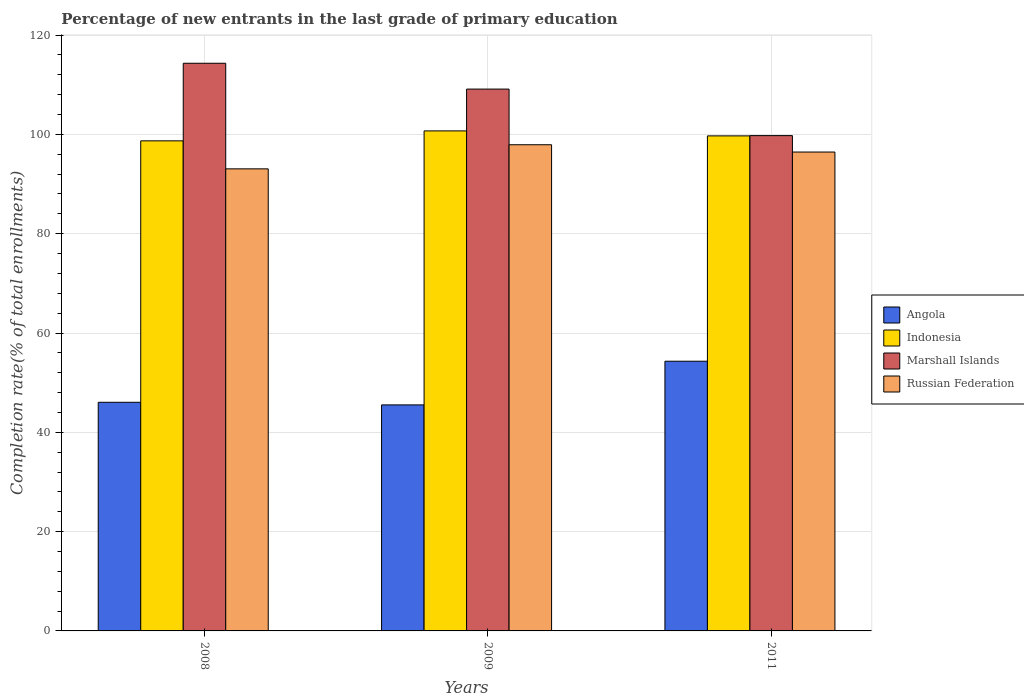How many different coloured bars are there?
Your answer should be very brief. 4. Are the number of bars per tick equal to the number of legend labels?
Your answer should be compact. Yes. Are the number of bars on each tick of the X-axis equal?
Give a very brief answer. Yes. How many bars are there on the 2nd tick from the left?
Ensure brevity in your answer.  4. What is the label of the 1st group of bars from the left?
Give a very brief answer. 2008. What is the percentage of new entrants in Russian Federation in 2009?
Offer a terse response. 97.91. Across all years, what is the maximum percentage of new entrants in Marshall Islands?
Your answer should be very brief. 114.33. Across all years, what is the minimum percentage of new entrants in Marshall Islands?
Give a very brief answer. 99.75. In which year was the percentage of new entrants in Marshall Islands minimum?
Offer a terse response. 2011. What is the total percentage of new entrants in Indonesia in the graph?
Provide a succinct answer. 299.1. What is the difference between the percentage of new entrants in Angola in 2008 and that in 2009?
Provide a short and direct response. 0.53. What is the difference between the percentage of new entrants in Indonesia in 2008 and the percentage of new entrants in Russian Federation in 2009?
Provide a succinct answer. 0.79. What is the average percentage of new entrants in Russian Federation per year?
Ensure brevity in your answer.  95.81. In the year 2009, what is the difference between the percentage of new entrants in Angola and percentage of new entrants in Russian Federation?
Your response must be concise. -52.39. What is the ratio of the percentage of new entrants in Russian Federation in 2009 to that in 2011?
Your answer should be compact. 1.02. What is the difference between the highest and the second highest percentage of new entrants in Russian Federation?
Your response must be concise. 1.47. What is the difference between the highest and the lowest percentage of new entrants in Russian Federation?
Your answer should be very brief. 4.85. What does the 4th bar from the left in 2009 represents?
Your response must be concise. Russian Federation. What does the 3rd bar from the right in 2008 represents?
Provide a succinct answer. Indonesia. Is it the case that in every year, the sum of the percentage of new entrants in Russian Federation and percentage of new entrants in Marshall Islands is greater than the percentage of new entrants in Angola?
Ensure brevity in your answer.  Yes. Are the values on the major ticks of Y-axis written in scientific E-notation?
Keep it short and to the point. No. How many legend labels are there?
Keep it short and to the point. 4. What is the title of the graph?
Your answer should be very brief. Percentage of new entrants in the last grade of primary education. What is the label or title of the X-axis?
Provide a short and direct response. Years. What is the label or title of the Y-axis?
Keep it short and to the point. Completion rate(% of total enrollments). What is the Completion rate(% of total enrollments) in Angola in 2008?
Give a very brief answer. 46.05. What is the Completion rate(% of total enrollments) in Indonesia in 2008?
Your answer should be compact. 98.7. What is the Completion rate(% of total enrollments) of Marshall Islands in 2008?
Your response must be concise. 114.33. What is the Completion rate(% of total enrollments) of Russian Federation in 2008?
Offer a very short reply. 93.06. What is the Completion rate(% of total enrollments) of Angola in 2009?
Offer a terse response. 45.52. What is the Completion rate(% of total enrollments) in Indonesia in 2009?
Offer a terse response. 100.7. What is the Completion rate(% of total enrollments) of Marshall Islands in 2009?
Provide a short and direct response. 109.12. What is the Completion rate(% of total enrollments) in Russian Federation in 2009?
Your answer should be compact. 97.91. What is the Completion rate(% of total enrollments) in Angola in 2011?
Your response must be concise. 54.32. What is the Completion rate(% of total enrollments) of Indonesia in 2011?
Provide a succinct answer. 99.7. What is the Completion rate(% of total enrollments) of Marshall Islands in 2011?
Ensure brevity in your answer.  99.75. What is the Completion rate(% of total enrollments) in Russian Federation in 2011?
Offer a terse response. 96.45. Across all years, what is the maximum Completion rate(% of total enrollments) in Angola?
Your answer should be very brief. 54.32. Across all years, what is the maximum Completion rate(% of total enrollments) in Indonesia?
Give a very brief answer. 100.7. Across all years, what is the maximum Completion rate(% of total enrollments) in Marshall Islands?
Your answer should be compact. 114.33. Across all years, what is the maximum Completion rate(% of total enrollments) in Russian Federation?
Provide a succinct answer. 97.91. Across all years, what is the minimum Completion rate(% of total enrollments) in Angola?
Keep it short and to the point. 45.52. Across all years, what is the minimum Completion rate(% of total enrollments) in Indonesia?
Your response must be concise. 98.7. Across all years, what is the minimum Completion rate(% of total enrollments) in Marshall Islands?
Make the answer very short. 99.75. Across all years, what is the minimum Completion rate(% of total enrollments) of Russian Federation?
Provide a succinct answer. 93.06. What is the total Completion rate(% of total enrollments) of Angola in the graph?
Your answer should be compact. 145.89. What is the total Completion rate(% of total enrollments) of Indonesia in the graph?
Keep it short and to the point. 299.1. What is the total Completion rate(% of total enrollments) of Marshall Islands in the graph?
Provide a short and direct response. 323.2. What is the total Completion rate(% of total enrollments) of Russian Federation in the graph?
Make the answer very short. 287.42. What is the difference between the Completion rate(% of total enrollments) of Angola in 2008 and that in 2009?
Offer a terse response. 0.53. What is the difference between the Completion rate(% of total enrollments) in Indonesia in 2008 and that in 2009?
Your response must be concise. -2. What is the difference between the Completion rate(% of total enrollments) of Marshall Islands in 2008 and that in 2009?
Offer a very short reply. 5.2. What is the difference between the Completion rate(% of total enrollments) in Russian Federation in 2008 and that in 2009?
Your answer should be compact. -4.85. What is the difference between the Completion rate(% of total enrollments) of Angola in 2008 and that in 2011?
Offer a very short reply. -8.27. What is the difference between the Completion rate(% of total enrollments) in Indonesia in 2008 and that in 2011?
Your answer should be compact. -1. What is the difference between the Completion rate(% of total enrollments) in Marshall Islands in 2008 and that in 2011?
Provide a succinct answer. 14.57. What is the difference between the Completion rate(% of total enrollments) of Russian Federation in 2008 and that in 2011?
Ensure brevity in your answer.  -3.39. What is the difference between the Completion rate(% of total enrollments) in Angola in 2009 and that in 2011?
Provide a succinct answer. -8.8. What is the difference between the Completion rate(% of total enrollments) of Marshall Islands in 2009 and that in 2011?
Make the answer very short. 9.37. What is the difference between the Completion rate(% of total enrollments) of Russian Federation in 2009 and that in 2011?
Offer a very short reply. 1.47. What is the difference between the Completion rate(% of total enrollments) in Angola in 2008 and the Completion rate(% of total enrollments) in Indonesia in 2009?
Make the answer very short. -54.66. What is the difference between the Completion rate(% of total enrollments) of Angola in 2008 and the Completion rate(% of total enrollments) of Marshall Islands in 2009?
Provide a short and direct response. -63.08. What is the difference between the Completion rate(% of total enrollments) of Angola in 2008 and the Completion rate(% of total enrollments) of Russian Federation in 2009?
Your response must be concise. -51.87. What is the difference between the Completion rate(% of total enrollments) of Indonesia in 2008 and the Completion rate(% of total enrollments) of Marshall Islands in 2009?
Give a very brief answer. -10.42. What is the difference between the Completion rate(% of total enrollments) of Indonesia in 2008 and the Completion rate(% of total enrollments) of Russian Federation in 2009?
Give a very brief answer. 0.79. What is the difference between the Completion rate(% of total enrollments) in Marshall Islands in 2008 and the Completion rate(% of total enrollments) in Russian Federation in 2009?
Provide a succinct answer. 16.41. What is the difference between the Completion rate(% of total enrollments) in Angola in 2008 and the Completion rate(% of total enrollments) in Indonesia in 2011?
Your response must be concise. -53.65. What is the difference between the Completion rate(% of total enrollments) in Angola in 2008 and the Completion rate(% of total enrollments) in Marshall Islands in 2011?
Provide a short and direct response. -53.71. What is the difference between the Completion rate(% of total enrollments) of Angola in 2008 and the Completion rate(% of total enrollments) of Russian Federation in 2011?
Offer a very short reply. -50.4. What is the difference between the Completion rate(% of total enrollments) in Indonesia in 2008 and the Completion rate(% of total enrollments) in Marshall Islands in 2011?
Your response must be concise. -1.05. What is the difference between the Completion rate(% of total enrollments) of Indonesia in 2008 and the Completion rate(% of total enrollments) of Russian Federation in 2011?
Offer a very short reply. 2.25. What is the difference between the Completion rate(% of total enrollments) in Marshall Islands in 2008 and the Completion rate(% of total enrollments) in Russian Federation in 2011?
Keep it short and to the point. 17.88. What is the difference between the Completion rate(% of total enrollments) of Angola in 2009 and the Completion rate(% of total enrollments) of Indonesia in 2011?
Your answer should be compact. -54.18. What is the difference between the Completion rate(% of total enrollments) in Angola in 2009 and the Completion rate(% of total enrollments) in Marshall Islands in 2011?
Ensure brevity in your answer.  -54.23. What is the difference between the Completion rate(% of total enrollments) of Angola in 2009 and the Completion rate(% of total enrollments) of Russian Federation in 2011?
Give a very brief answer. -50.93. What is the difference between the Completion rate(% of total enrollments) of Indonesia in 2009 and the Completion rate(% of total enrollments) of Marshall Islands in 2011?
Provide a succinct answer. 0.95. What is the difference between the Completion rate(% of total enrollments) in Indonesia in 2009 and the Completion rate(% of total enrollments) in Russian Federation in 2011?
Give a very brief answer. 4.26. What is the difference between the Completion rate(% of total enrollments) of Marshall Islands in 2009 and the Completion rate(% of total enrollments) of Russian Federation in 2011?
Give a very brief answer. 12.68. What is the average Completion rate(% of total enrollments) of Angola per year?
Offer a terse response. 48.63. What is the average Completion rate(% of total enrollments) of Indonesia per year?
Provide a short and direct response. 99.7. What is the average Completion rate(% of total enrollments) in Marshall Islands per year?
Keep it short and to the point. 107.73. What is the average Completion rate(% of total enrollments) in Russian Federation per year?
Make the answer very short. 95.81. In the year 2008, what is the difference between the Completion rate(% of total enrollments) in Angola and Completion rate(% of total enrollments) in Indonesia?
Give a very brief answer. -52.65. In the year 2008, what is the difference between the Completion rate(% of total enrollments) of Angola and Completion rate(% of total enrollments) of Marshall Islands?
Your answer should be very brief. -68.28. In the year 2008, what is the difference between the Completion rate(% of total enrollments) in Angola and Completion rate(% of total enrollments) in Russian Federation?
Ensure brevity in your answer.  -47.01. In the year 2008, what is the difference between the Completion rate(% of total enrollments) in Indonesia and Completion rate(% of total enrollments) in Marshall Islands?
Provide a short and direct response. -15.63. In the year 2008, what is the difference between the Completion rate(% of total enrollments) in Indonesia and Completion rate(% of total enrollments) in Russian Federation?
Offer a very short reply. 5.64. In the year 2008, what is the difference between the Completion rate(% of total enrollments) of Marshall Islands and Completion rate(% of total enrollments) of Russian Federation?
Offer a very short reply. 21.27. In the year 2009, what is the difference between the Completion rate(% of total enrollments) of Angola and Completion rate(% of total enrollments) of Indonesia?
Give a very brief answer. -55.18. In the year 2009, what is the difference between the Completion rate(% of total enrollments) in Angola and Completion rate(% of total enrollments) in Marshall Islands?
Ensure brevity in your answer.  -63.6. In the year 2009, what is the difference between the Completion rate(% of total enrollments) of Angola and Completion rate(% of total enrollments) of Russian Federation?
Offer a very short reply. -52.39. In the year 2009, what is the difference between the Completion rate(% of total enrollments) of Indonesia and Completion rate(% of total enrollments) of Marshall Islands?
Your answer should be compact. -8.42. In the year 2009, what is the difference between the Completion rate(% of total enrollments) in Indonesia and Completion rate(% of total enrollments) in Russian Federation?
Ensure brevity in your answer.  2.79. In the year 2009, what is the difference between the Completion rate(% of total enrollments) of Marshall Islands and Completion rate(% of total enrollments) of Russian Federation?
Ensure brevity in your answer.  11.21. In the year 2011, what is the difference between the Completion rate(% of total enrollments) of Angola and Completion rate(% of total enrollments) of Indonesia?
Your response must be concise. -45.38. In the year 2011, what is the difference between the Completion rate(% of total enrollments) of Angola and Completion rate(% of total enrollments) of Marshall Islands?
Your answer should be very brief. -45.44. In the year 2011, what is the difference between the Completion rate(% of total enrollments) in Angola and Completion rate(% of total enrollments) in Russian Federation?
Give a very brief answer. -42.13. In the year 2011, what is the difference between the Completion rate(% of total enrollments) in Indonesia and Completion rate(% of total enrollments) in Marshall Islands?
Make the answer very short. -0.05. In the year 2011, what is the difference between the Completion rate(% of total enrollments) of Indonesia and Completion rate(% of total enrollments) of Russian Federation?
Keep it short and to the point. 3.25. In the year 2011, what is the difference between the Completion rate(% of total enrollments) of Marshall Islands and Completion rate(% of total enrollments) of Russian Federation?
Your response must be concise. 3.31. What is the ratio of the Completion rate(% of total enrollments) in Angola in 2008 to that in 2009?
Your response must be concise. 1.01. What is the ratio of the Completion rate(% of total enrollments) of Indonesia in 2008 to that in 2009?
Offer a very short reply. 0.98. What is the ratio of the Completion rate(% of total enrollments) in Marshall Islands in 2008 to that in 2009?
Keep it short and to the point. 1.05. What is the ratio of the Completion rate(% of total enrollments) of Russian Federation in 2008 to that in 2009?
Your answer should be very brief. 0.95. What is the ratio of the Completion rate(% of total enrollments) of Angola in 2008 to that in 2011?
Give a very brief answer. 0.85. What is the ratio of the Completion rate(% of total enrollments) in Indonesia in 2008 to that in 2011?
Give a very brief answer. 0.99. What is the ratio of the Completion rate(% of total enrollments) of Marshall Islands in 2008 to that in 2011?
Keep it short and to the point. 1.15. What is the ratio of the Completion rate(% of total enrollments) in Russian Federation in 2008 to that in 2011?
Offer a terse response. 0.96. What is the ratio of the Completion rate(% of total enrollments) of Angola in 2009 to that in 2011?
Offer a very short reply. 0.84. What is the ratio of the Completion rate(% of total enrollments) of Marshall Islands in 2009 to that in 2011?
Your response must be concise. 1.09. What is the ratio of the Completion rate(% of total enrollments) in Russian Federation in 2009 to that in 2011?
Offer a very short reply. 1.02. What is the difference between the highest and the second highest Completion rate(% of total enrollments) in Angola?
Offer a very short reply. 8.27. What is the difference between the highest and the second highest Completion rate(% of total enrollments) in Marshall Islands?
Your answer should be compact. 5.2. What is the difference between the highest and the second highest Completion rate(% of total enrollments) in Russian Federation?
Give a very brief answer. 1.47. What is the difference between the highest and the lowest Completion rate(% of total enrollments) in Angola?
Provide a succinct answer. 8.8. What is the difference between the highest and the lowest Completion rate(% of total enrollments) of Indonesia?
Provide a short and direct response. 2. What is the difference between the highest and the lowest Completion rate(% of total enrollments) of Marshall Islands?
Your response must be concise. 14.57. What is the difference between the highest and the lowest Completion rate(% of total enrollments) in Russian Federation?
Your response must be concise. 4.85. 